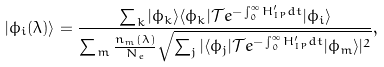<formula> <loc_0><loc_0><loc_500><loc_500>| \phi _ { i } ( \lambda ) \rangle = \frac { \sum _ { k } | \phi _ { k } \rangle \langle \phi _ { k } | \mathcal { T } e ^ { - \int _ { 0 } ^ { \infty } H ^ { \prime } _ { I P } d t } | \phi _ { i } \rangle } { \sum _ { m } \frac { n _ { m } ( \lambda ) } { N _ { e } } \sqrt { \sum _ { j } | \langle \phi _ { j } | \mathcal { T } e ^ { - \int _ { 0 } ^ { \infty } H ^ { \prime } _ { I P } d t } | \phi _ { m } \rangle | ^ { 2 } } } ,</formula> 